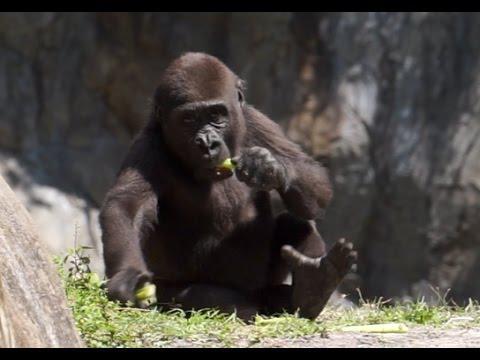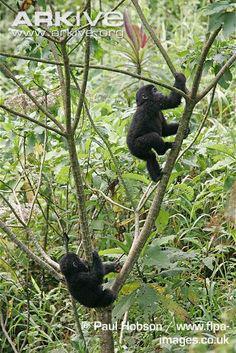The first image is the image on the left, the second image is the image on the right. For the images displayed, is the sentence "One image shows two young gorillas playing on a tree branch, and one of them is climbing up the branch." factually correct? Answer yes or no. Yes. The first image is the image on the left, the second image is the image on the right. Given the left and right images, does the statement "The left image contains no more than one gorilla." hold true? Answer yes or no. Yes. 